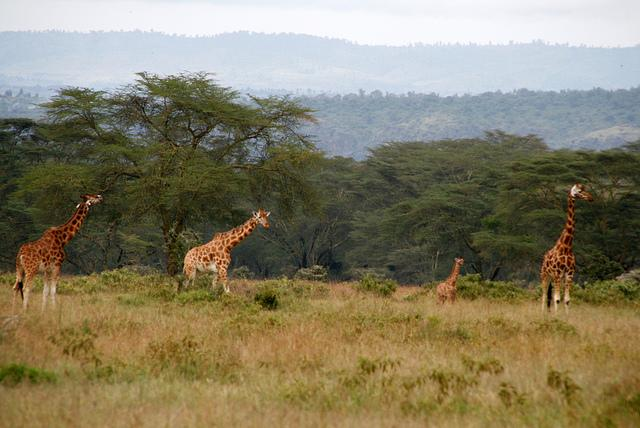What direction are the giraffes looking? Please explain your reasoning. east. The animals are looking to the right. 